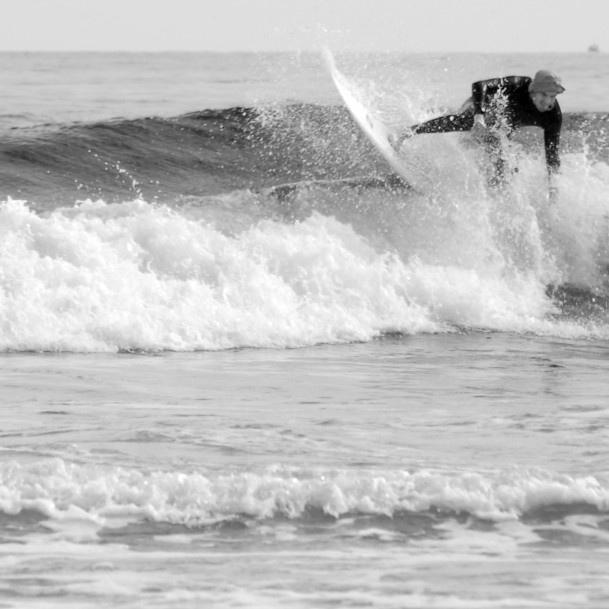Is the man about to fall?
Be succinct. Yes. Is the water cold?
Short answer required. Yes. What is he wearing?
Concise answer only. Wetsuit. Will the surfer fall?
Concise answer only. Yes. 